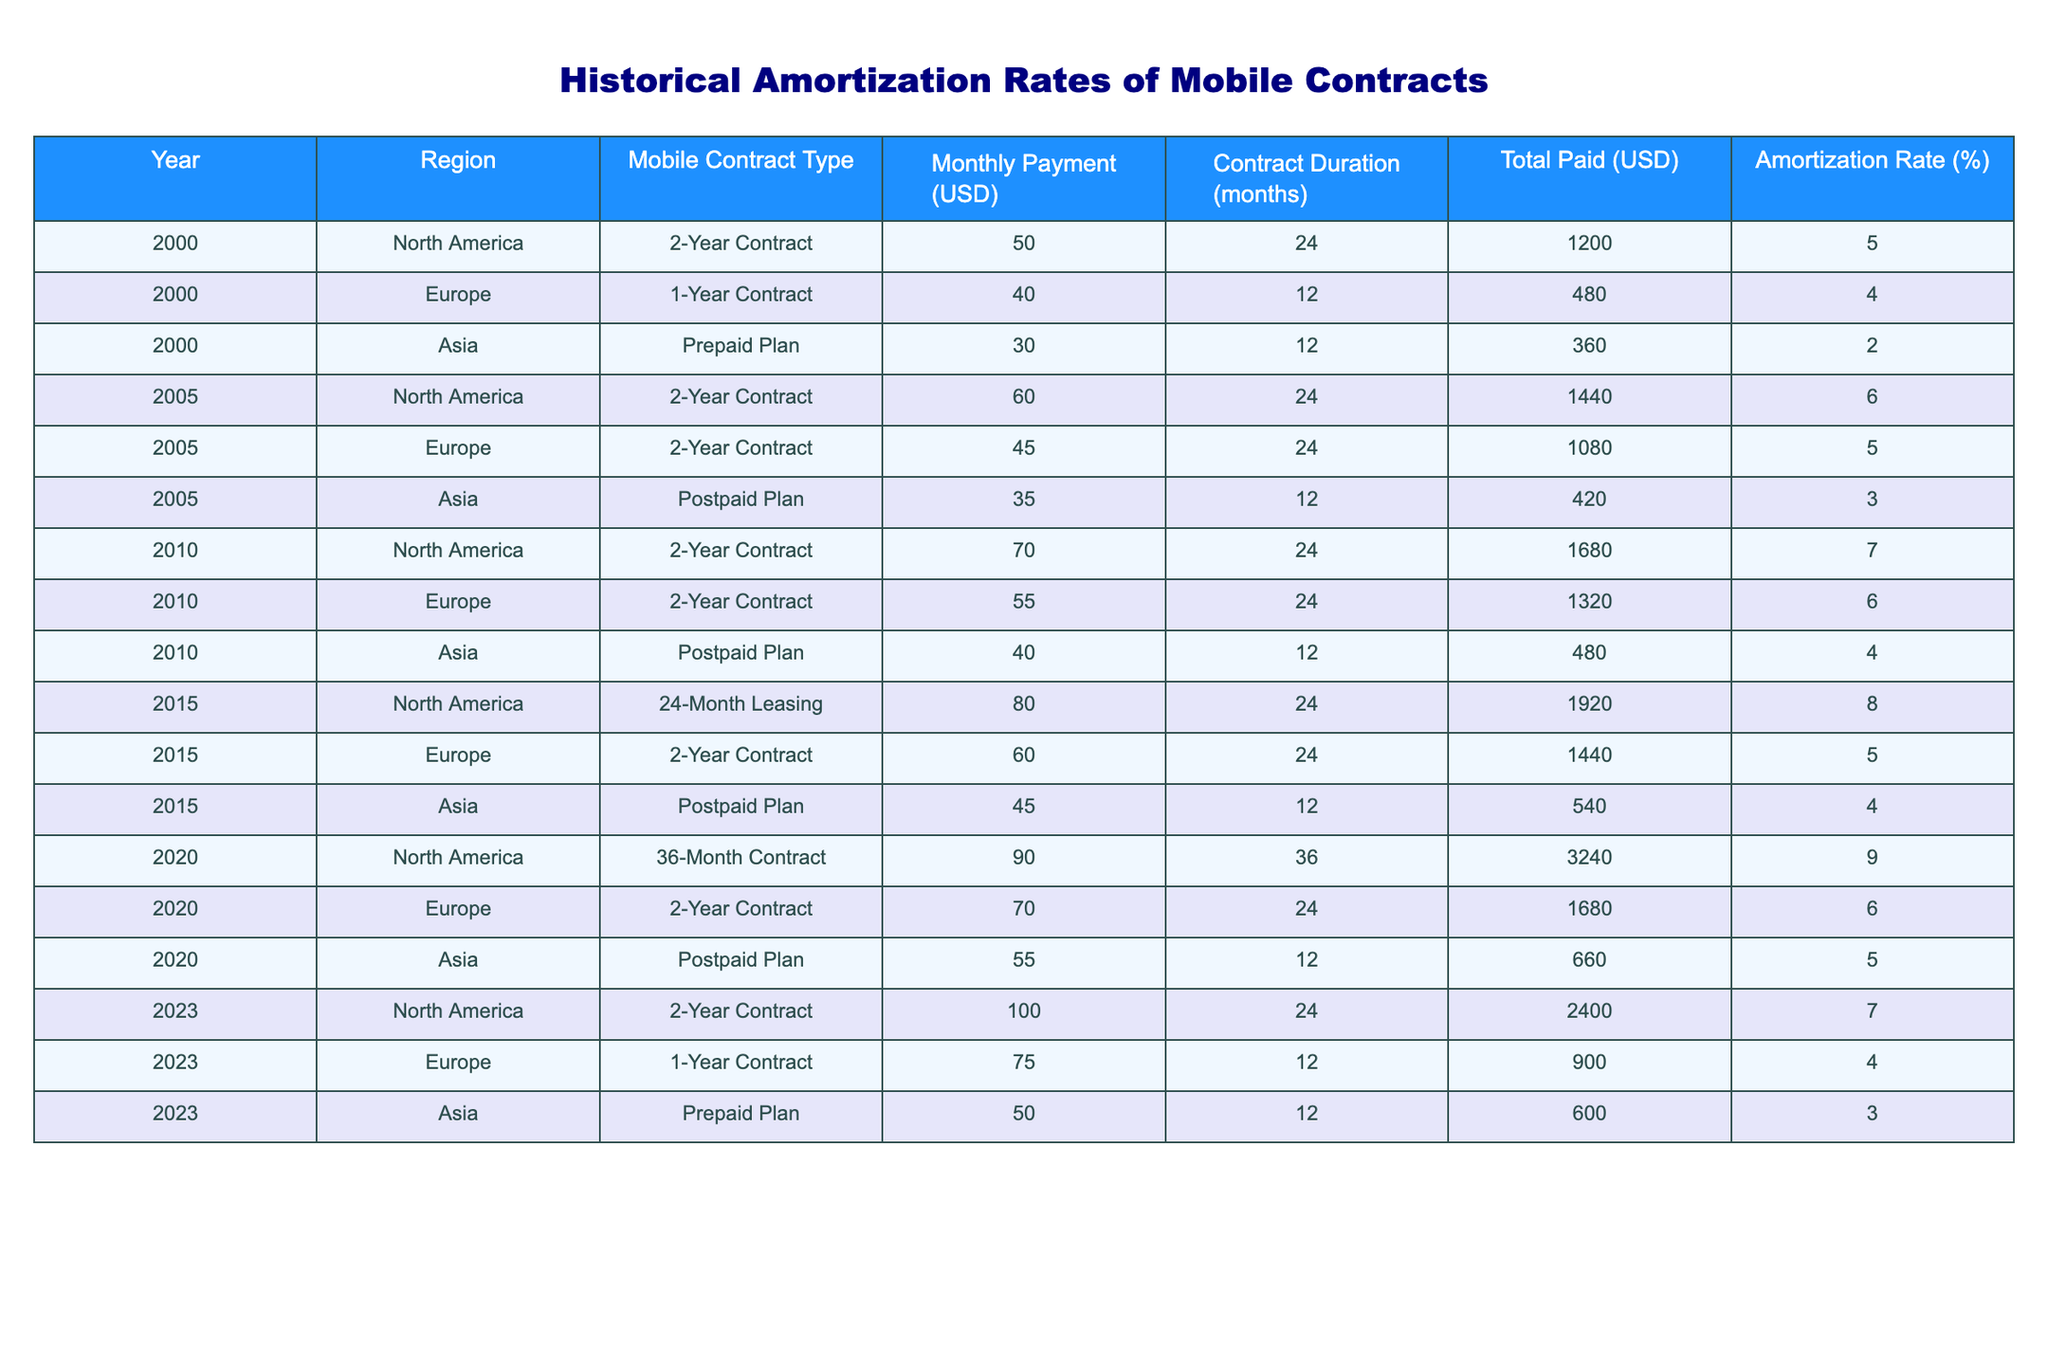What was the total paid for the 2-Year Contract in North America in 2010? In 2010, the monthly payment for the 2-Year Contract in North America was 70 USD, and the contract duration was 24 months. Therefore, the total paid is calculated as 70 USD multiplied by 24 months, which results in 1680 USD.
Answer: 1680 USD What is the amortization rate for the 1-Year Contract in Europe in 2023? The amortization rate for the 1-Year Contract in Europe in 2023 is explicitly stated in the table, which shows a rate of 4%.
Answer: 4% Is the monthly payment for the Postpaid Plan in Asia higher in 2015 than in 2010? In 2010, the monthly payment for the Postpaid Plan in Asia was 40 USD, while in 2015 it was 45 USD. Since 45 USD is greater than 40 USD, the answer is yes.
Answer: Yes What was the average amortization rate across all regions for the year 2020? In 2020, the amortization rates for North America, Europe, and Asia were 9%, 6%, and 5%, respectively. To calculate the average, we sum these rates (9 + 6 + 5 = 20) and divide by the number of regions (3), giving us an average of 20/3 ≈ 6.67%.
Answer: Approximately 6.67% Did the total amount paid for 36-Month Contracts in North America increase from 2020 to 2023? In 2020, the total paid for the 36-Month Contract in North America was 3240 USD, and in 2023, it was 2400 USD for a 2-Year Contract. Since 2400 USD is less than 3240 USD, the total amount paid actually decreased.
Answer: No What was the highest amortization rate recorded for any contract type in North America from 2000 to 2023? Reviewing the table, we find that the highest amortization rate for North America was 9%, recorded for the 36-Month Contract in 2020.
Answer: 9% How does the total paid for the 24-Month Leasing in North America in 2015 compare to the 2-Year Contract in Europe for the same year? The total paid for the 24-Month Leasing in North America was 1920 USD, while the total paid for the 2-Year Contract in Europe was 1440 USD in 2015. Comparing the two, 1920 USD is higher than 1440 USD.
Answer: 1920 USD is higher What was the overall trend in amortization rates for mobile contracts in North America from 2000 to 2023? The amortization rates in North America are as follows: 5% in 2000, 6% in 2005, 7% in 2010, 8% in 2015, 9% in 2020, and 7% in 2023. Analyzing these rates, we observe an increasing trend from 2000 to 2020, then a decrease in 2023.
Answer: Increase then decrease What was the contract duration for the Prepaid Plan in Asia across the years listed? The Prepaid Plan in Asia consistently had a contract duration of 12 months for the years listed. This is confirmed from the data in the table across all years where this plan appears.
Answer: 12 months 